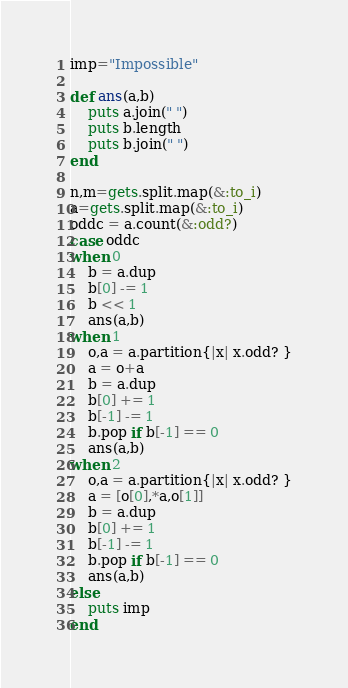Convert code to text. <code><loc_0><loc_0><loc_500><loc_500><_Ruby_>imp="Impossible"

def ans(a,b)
	puts a.join(" ")
	puts b.length
	puts b.join(" ")
end

n,m=gets.split.map(&:to_i)
a=gets.split.map(&:to_i)
oddc = a.count(&:odd?)
case oddc
when 0
	b = a.dup
	b[0] -= 1
	b << 1
	ans(a,b)
when 1
	o,a = a.partition{|x| x.odd? }
	a = o+a
	b = a.dup
	b[0] += 1
	b[-1] -= 1
	b.pop if b[-1] == 0
	ans(a,b)
when 2
	o,a = a.partition{|x| x.odd? }
	a = [o[0],*a,o[1]]
	b = a.dup
	b[0] += 1
	b[-1] -= 1
	b.pop if b[-1] == 0
	ans(a,b)
else
	puts imp
end
</code> 